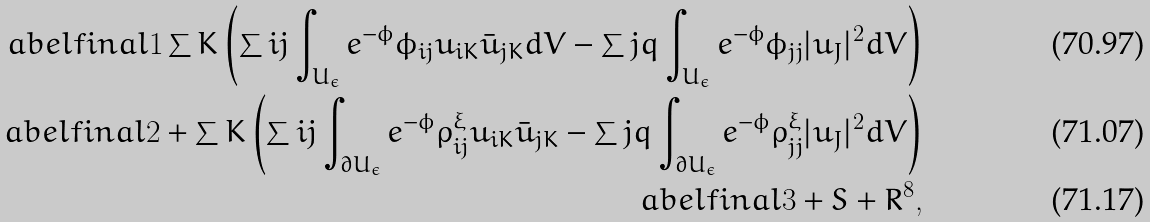<formula> <loc_0><loc_0><loc_500><loc_500>\L a b e l { f i n a l 1 } \sum K \left ( \sum i j \int _ { U _ { \epsilon } } e ^ { - \phi } \phi _ { i j } u _ { i K } \bar { u } _ { j K } d V - \sum j q \int _ { U _ { \epsilon } } e ^ { - \phi } \phi _ { j j } | u _ { J } | ^ { 2 } d V \right ) \\ \L a b e l { f i n a l 2 } + \sum K \left ( \sum i j \int _ { \partial U _ { \epsilon } } e ^ { - \phi } \rho _ { i j } ^ { \xi } u _ { i K } \bar { u } _ { j K } - \sum j q \int _ { \partial U _ { \epsilon } } e ^ { - \phi } \rho _ { j j } ^ { \xi } | u _ { J } | ^ { 2 } d V \right ) \\ \L a b e l { f i n a l 3 } + S + R ^ { 8 } ,</formula> 